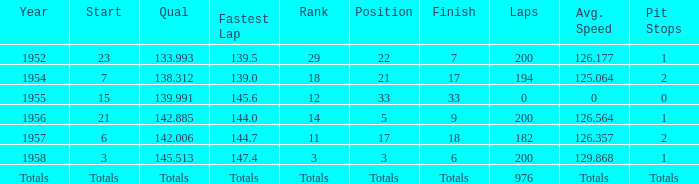Could you parse the entire table as a dict? {'header': ['Year', 'Start', 'Qual', 'Fastest Lap', 'Rank', 'Position', 'Finish', 'Laps', 'Avg. Speed', 'Pit Stops'], 'rows': [['1952', '23', '133.993', '139.5', '29', '22', '7', '200', '126.177', '1'], ['1954', '7', '138.312', '139.0', '18', '21', '17', '194', '125.064', '2'], ['1955', '15', '139.991', '145.6', '12', '33', '33', '0', '0', '0'], ['1956', '21', '142.885', '144.0', '14', '5', '9', '200', '126.564', '1'], ['1957', '6', '142.006', '144.7', '11', '17', '18', '182', '126.357', '2'], ['1958', '3', '145.513', '147.4', '3', '3', '6', '200', '129.868', '1'], ['Totals', 'Totals', 'Totals', 'Totals', 'Totals', 'Totals', 'Totals', '976', 'Totals', 'Totals']]} What place did Jimmy Reece start from when he ranked 12? 15.0. 